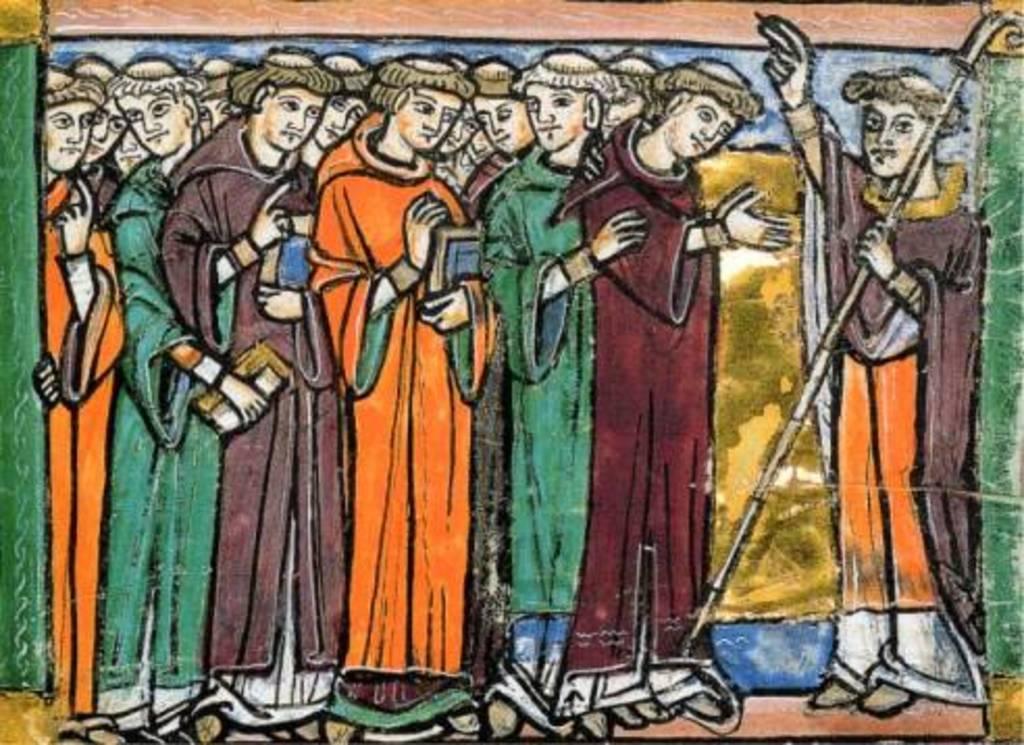Could you give a brief overview of what you see in this image? In this picture we can see painting of few people. 